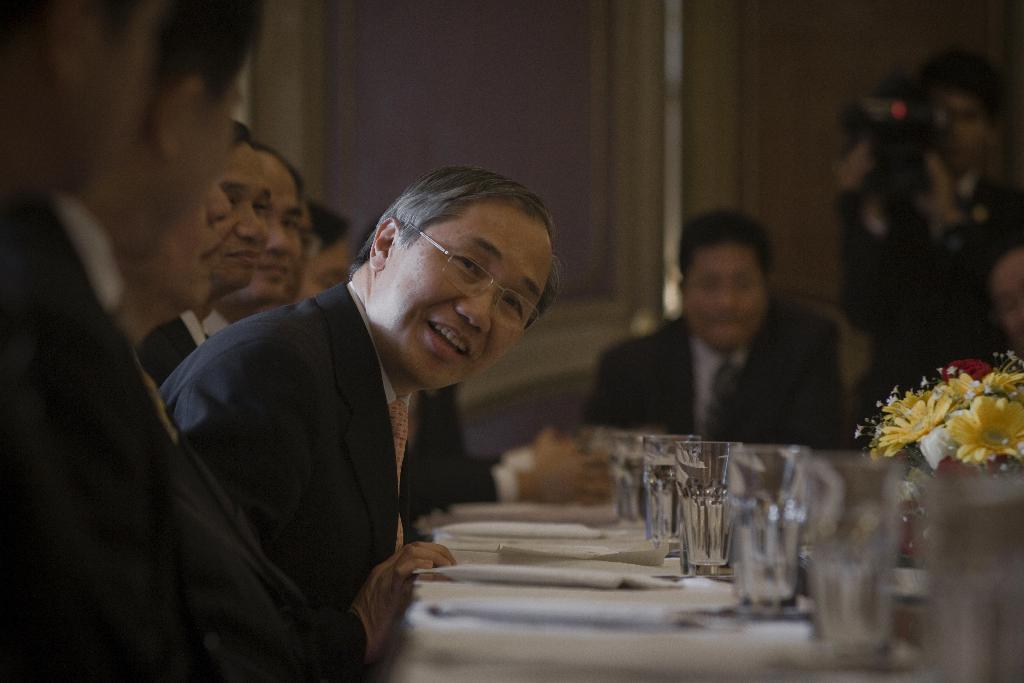Could you give a brief overview of what you see in this image? In this image there are persons sitting. In the center there is a table and on the table there are plates, glasses and there are flowers. In the background there is a man standing and holding a camera. 